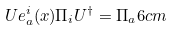<formula> <loc_0><loc_0><loc_500><loc_500>U e _ { a } ^ { i } ( x ) \Pi _ { i } U ^ { \dagger } = \Pi _ { a } 6 c m</formula> 